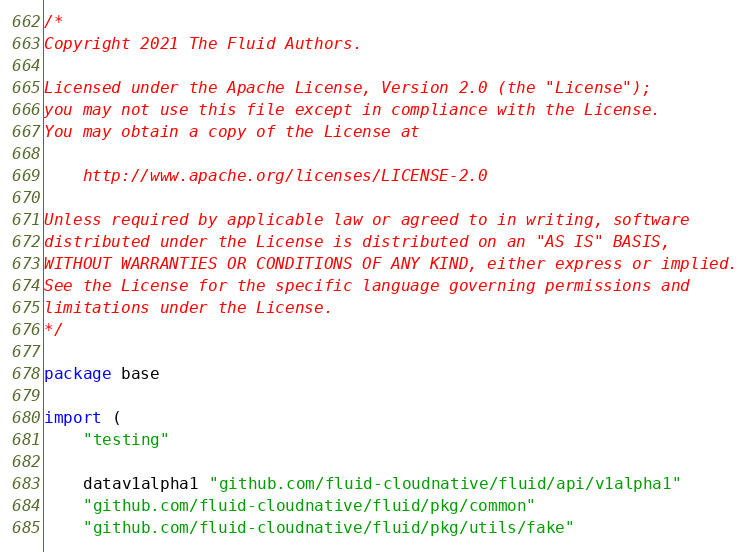Convert code to text. <code><loc_0><loc_0><loc_500><loc_500><_Go_>/*
Copyright 2021 The Fluid Authors.

Licensed under the Apache License, Version 2.0 (the "License");
you may not use this file except in compliance with the License.
You may obtain a copy of the License at

    http://www.apache.org/licenses/LICENSE-2.0

Unless required by applicable law or agreed to in writing, software
distributed under the License is distributed on an "AS IS" BASIS,
WITHOUT WARRANTIES OR CONDITIONS OF ANY KIND, either express or implied.
See the License for the specific language governing permissions and
limitations under the License.
*/

package base

import (
	"testing"

	datav1alpha1 "github.com/fluid-cloudnative/fluid/api/v1alpha1"
	"github.com/fluid-cloudnative/fluid/pkg/common"
	"github.com/fluid-cloudnative/fluid/pkg/utils/fake"</code> 